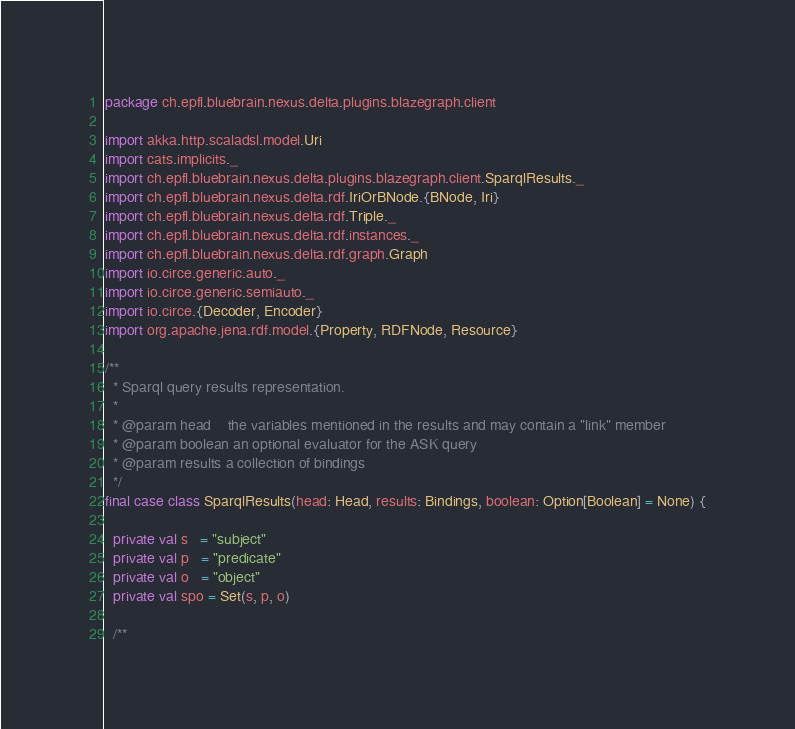<code> <loc_0><loc_0><loc_500><loc_500><_Scala_>package ch.epfl.bluebrain.nexus.delta.plugins.blazegraph.client

import akka.http.scaladsl.model.Uri
import cats.implicits._
import ch.epfl.bluebrain.nexus.delta.plugins.blazegraph.client.SparqlResults._
import ch.epfl.bluebrain.nexus.delta.rdf.IriOrBNode.{BNode, Iri}
import ch.epfl.bluebrain.nexus.delta.rdf.Triple._
import ch.epfl.bluebrain.nexus.delta.rdf.instances._
import ch.epfl.bluebrain.nexus.delta.rdf.graph.Graph
import io.circe.generic.auto._
import io.circe.generic.semiauto._
import io.circe.{Decoder, Encoder}
import org.apache.jena.rdf.model.{Property, RDFNode, Resource}

/**
  * Sparql query results representation.
  *
  * @param head    the variables mentioned in the results and may contain a "link" member
  * @param boolean an optional evaluator for the ASK query
  * @param results a collection of bindings
  */
final case class SparqlResults(head: Head, results: Bindings, boolean: Option[Boolean] = None) {

  private val s   = "subject"
  private val p   = "predicate"
  private val o   = "object"
  private val spo = Set(s, p, o)

  /**</code> 